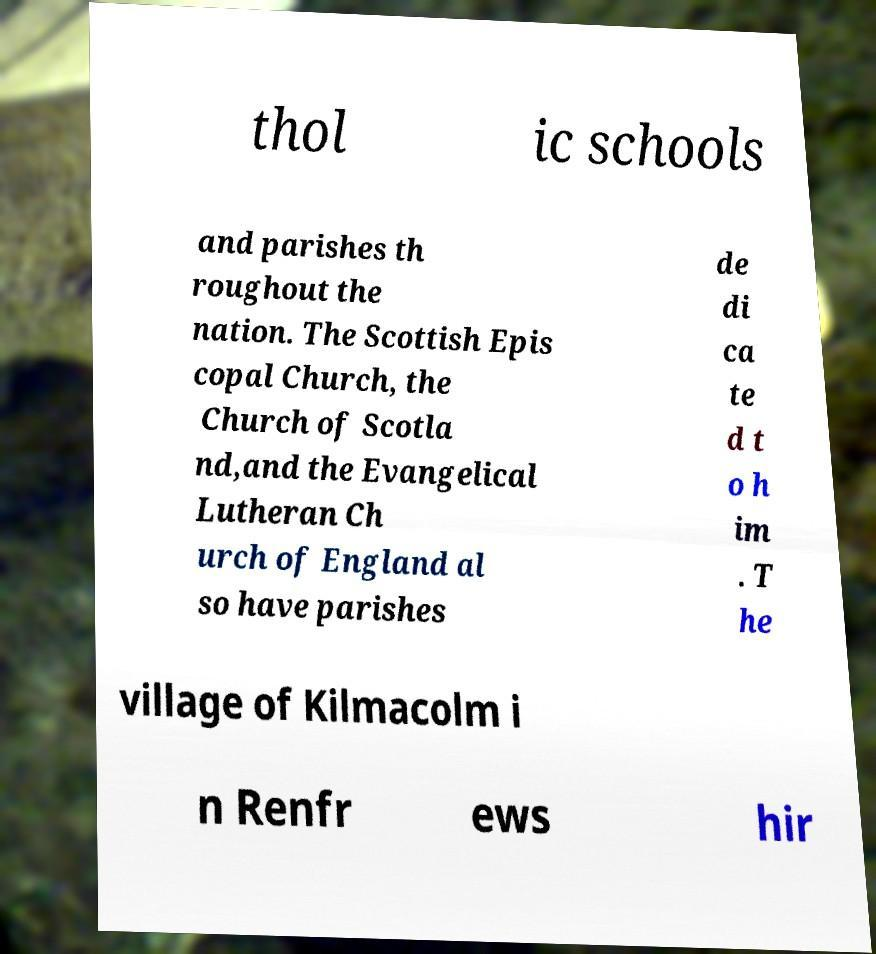Please read and relay the text visible in this image. What does it say? thol ic schools and parishes th roughout the nation. The Scottish Epis copal Church, the Church of Scotla nd,and the Evangelical Lutheran Ch urch of England al so have parishes de di ca te d t o h im . T he village of Kilmacolm i n Renfr ews hir 